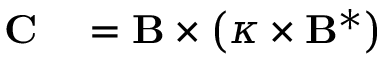<formula> <loc_0><loc_0><loc_500><loc_500>\begin{array} { r l } { C } & = B \times \left ( \kappa \times B ^ { * } \right ) } \end{array}</formula> 